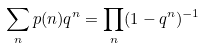<formula> <loc_0><loc_0><loc_500><loc_500>\sum _ { n } p ( n ) q ^ { n } = \prod _ { n } ( 1 - q ^ { n } ) ^ { - 1 }</formula> 